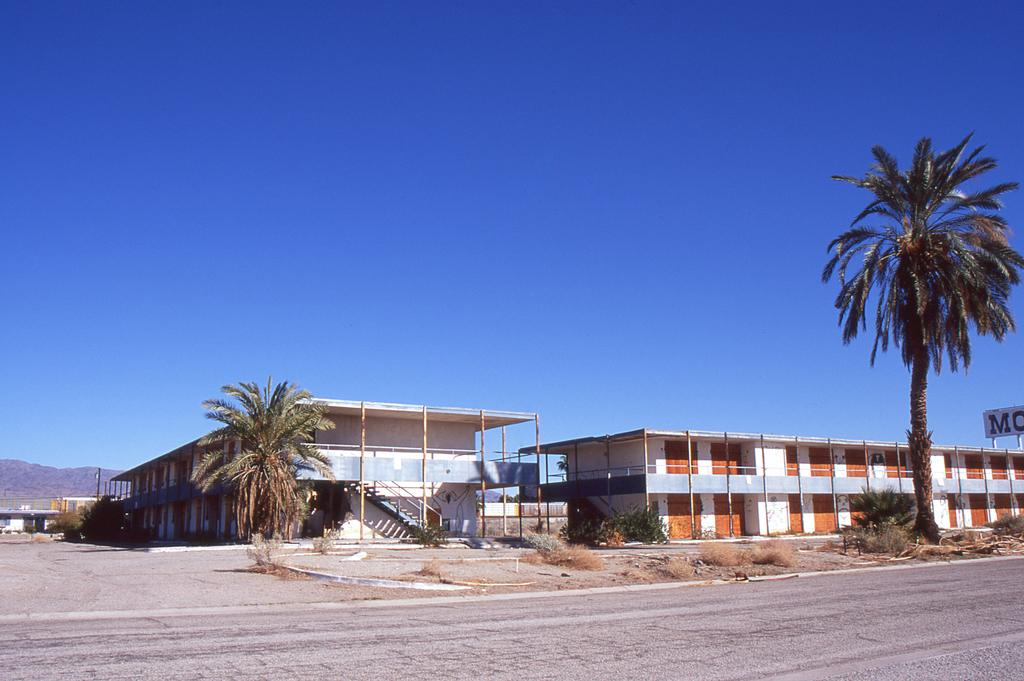What structures are located in the middle of the image? There are buildings in the middle of the image. What is at the bottom of the image? There is a road at the bottom of the image. What type of vegetation is on either side of the image? There are trees on either side of the image. What is visible at the top of the image? The sky is visible at the top of the image. How many pies can be seen floating on the waves in the image? There are no pies or waves present in the image. What type of toy is visible on the road in the image? There is no toy visible on the road in the image. 